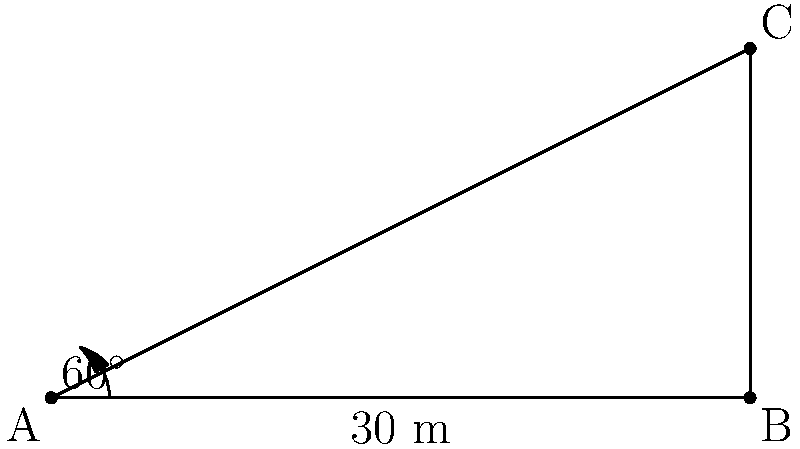At the St. Thomas Church in Chennai, a historian is studying the architectural influence of Portuguese missionaries. To measure the height of the church steeple, the historian stands 30 meters away from its base. Using an inclinometer, they measure the angle of elevation to the top of the steeple to be 60°. Calculate the height of the steeple to the nearest meter. To solve this problem, we can use the tangent trigonometric function. Let's follow these steps:

1) In the right triangle formed by the historian's line of sight, we know:
   - The adjacent side (distance from the historian to the base) is 30 meters
   - The angle of elevation is 60°
   - We need to find the opposite side (height of the steeple)

2) The tangent of an angle in a right triangle is the ratio of the opposite side to the adjacent side:

   $$\tan \theta = \frac{\text{opposite}}{\text{adjacent}}$$

3) In this case:

   $$\tan 60° = \frac{\text{height}}{30}$$

4) We know that $\tan 60° = \sqrt{3}$, so we can write:

   $$\sqrt{3} = \frac{\text{height}}{30}$$

5) To solve for the height, multiply both sides by 30:

   $$30\sqrt{3} = \text{height}$$

6) Calculate:
   $$30\sqrt{3} \approx 51.96 \text{ meters}$$

7) Rounding to the nearest meter:

   Height ≈ 52 meters
Answer: 52 meters 